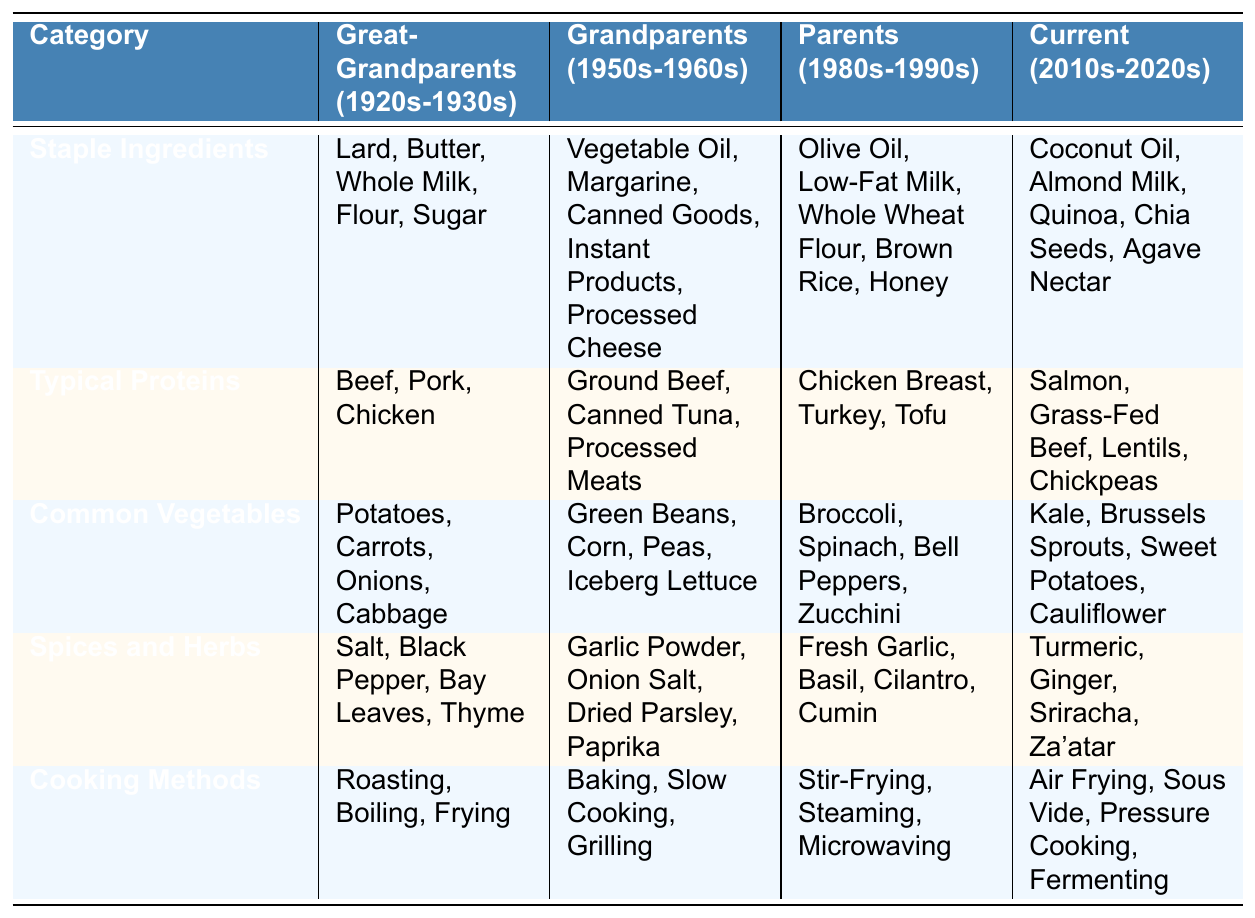What staple ingredients were used by Great-Grandparents? The table lists the staple ingredients for Great-Grandparents as Lard, Butter, Whole Milk, Flour, and Sugar.
Answer: Lard, Butter, Whole Milk, Flour, Sugar Which cooking methods were common in the Parents' generation? The table indicates that the cooking methods for Parents included Stir-Frying, Steaming, and Microwaving.
Answer: Stir-Frying, Steaming, Microwaving Did the Grandparents use fresh ingredients for proteins? The table shows that Grandparents primarily used Ground Beef, Canned Tuna, and Processed Meats, which are not fresh ingredients.
Answer: No What is the difference in the number of typical proteins between Great-Grandparents and Current generation? Great-Grandparents had 3 typical proteins (Beef, Pork, Chicken), while Current generation has 4 (Salmon, Grass-Fed Beef, Lentils, Chickpeas). The difference is 4 - 3 = 1.
Answer: 1 How many common vegetables did the Parents use compared to the Grandparents? Parents had 4 common vegetables (Broccoli, Spinach, Bell Peppers, Zucchini) and Grandparents also had 4 (Green Beans, Corn, Peas, Iceberg Lettuce). Therefore, both generations used the same number of common vegetables.
Answer: Same number (4) Which generation primarily used processed ingredients? The Grandparents' generation is noted for using Vegetable Oil, Margarine, Canned Goods, Instant Products, and Processed Cheese, indicating a reliance on processed ingredients.
Answer: Grandparents What is the trend of staple ingredients from Great-Grandparents to Current generation? Analyzing the staple ingredients, there is a shift from animal fats and dairy (Lard, Butter, Whole Milk) in Great-Grandparents to plant-based and health-focused ingredients (Coconut Oil, Almond Milk, Quinoa) in Current generation, showing a trend towards healthier choices.
Answer: Shift to healthier options Was there any overlap in common vegetables between Parents and Current generations? The common vegetables for Parents are Broccoli, Spinach, Bell Peppers, and Zucchini, while Current generation uses Kale, Brussels Sprouts, Sweet Potatoes, and Cauliflower. There is no overlap.
Answer: No overlap Which generation had the largest variety of spices and herbs? The Current generation has 4 unique spices and herbs (Turmeric, Ginger, Sriracha, Za'atar), compared to previous generations, but all generations have 4, indicating variety is similar across generations.
Answer: All generations had the same variety (4) How did the cooking methods change from Grandparents to Current generation? Grandparents used Baking, Slow Cooking, and Grilling, while Current generation uses Air Frying, Sous Vide, Pressure Cooking, and Fermenting, indicating a more diverse and modern approach to cooking methods.
Answer: More diverse and modern methods 